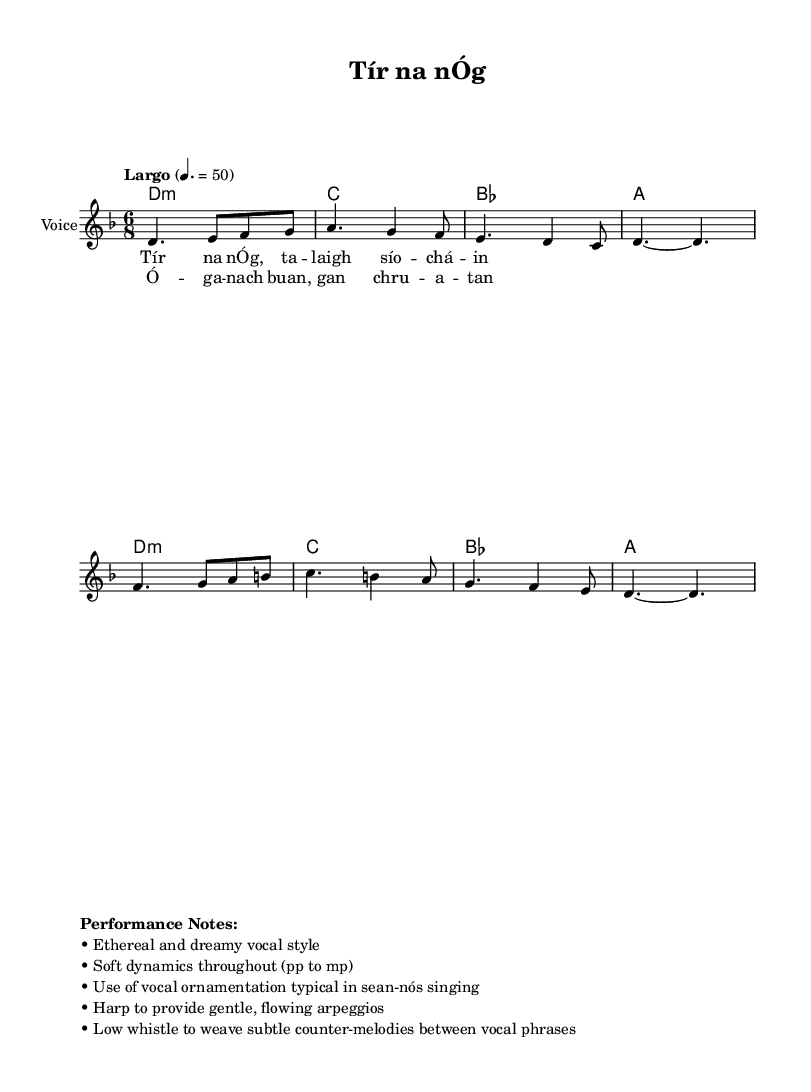What is the key signature of this music? The key signature is D minor, which has one flat (B flat). We identify the key signature by looking at the markings at the beginning of the staff.
Answer: D minor What is the time signature of this composition? The time signature is 6/8, indicated at the beginning of the score. This means there are six eighth notes per measure.
Answer: 6/8 What is the tempo marking of this piece? The tempo marking is "Largo," which typically indicates a slow tempo. The specific beats per minute are noted as 50.
Answer: Largo How many measures are in the melody section? Carefully counting the measures in the melody part, we find that there are four measures in total.
Answer: 4 What vocal style is recommended for this piece? The performance notes specify an "ethereal and dreamy vocal style," which suggests a soft and airy quality in the singing.
Answer: Ethereal How is the accompaniment structured in this song? The accompaniment uses chordal harmonies with a clear repetition, consisting of D minor, C major, B flat major, and A major chords, which create a soothing foundation for the vocals.
Answer: Chordal What type of ornamentation is suggested for the vocal performance? The performance notes suggest the use of vocal ornamentation typical in sean-nós singing, which incorporates embellishments and flourishes that are characteristic of this traditional style.
Answer: Sean-nós 